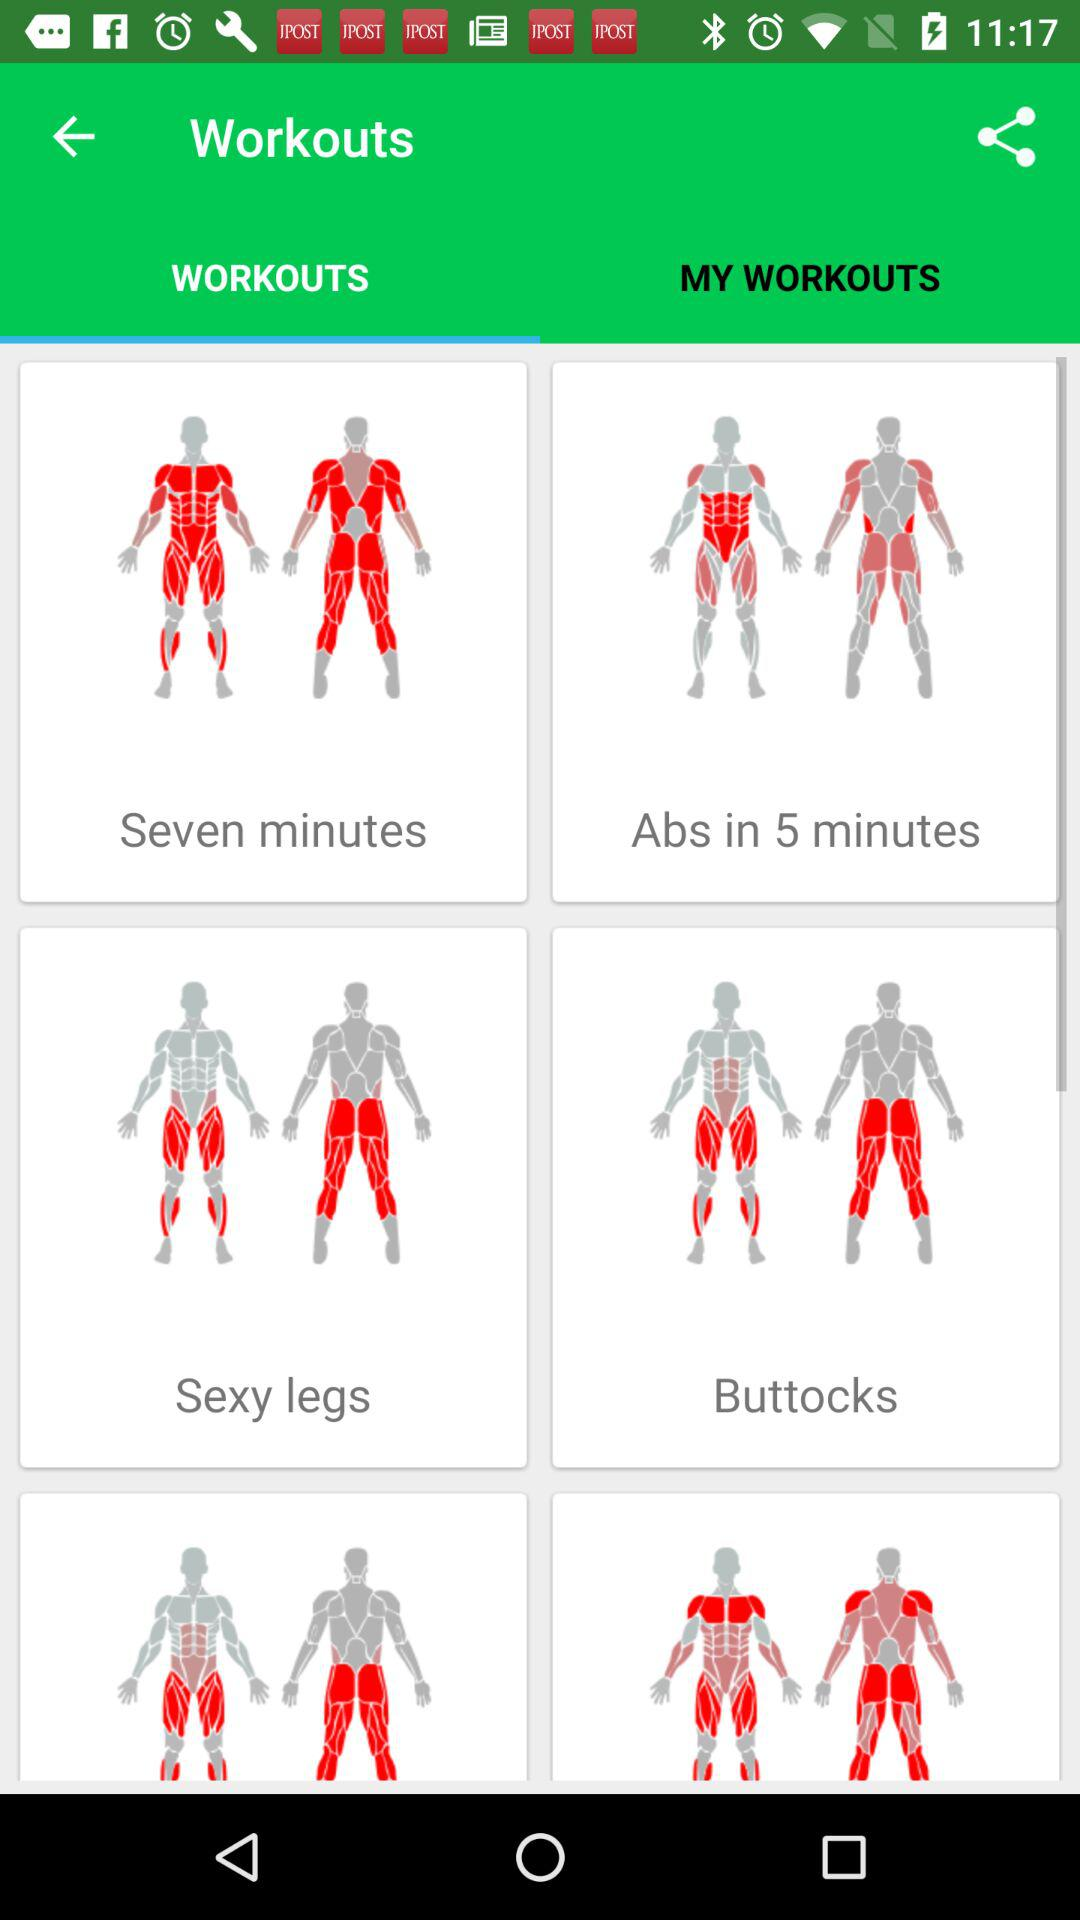What are the different workouts? The different workouts are "Seven minutes", "Abs in 5 minutes", "Sexy legs" and "Buttocks". 